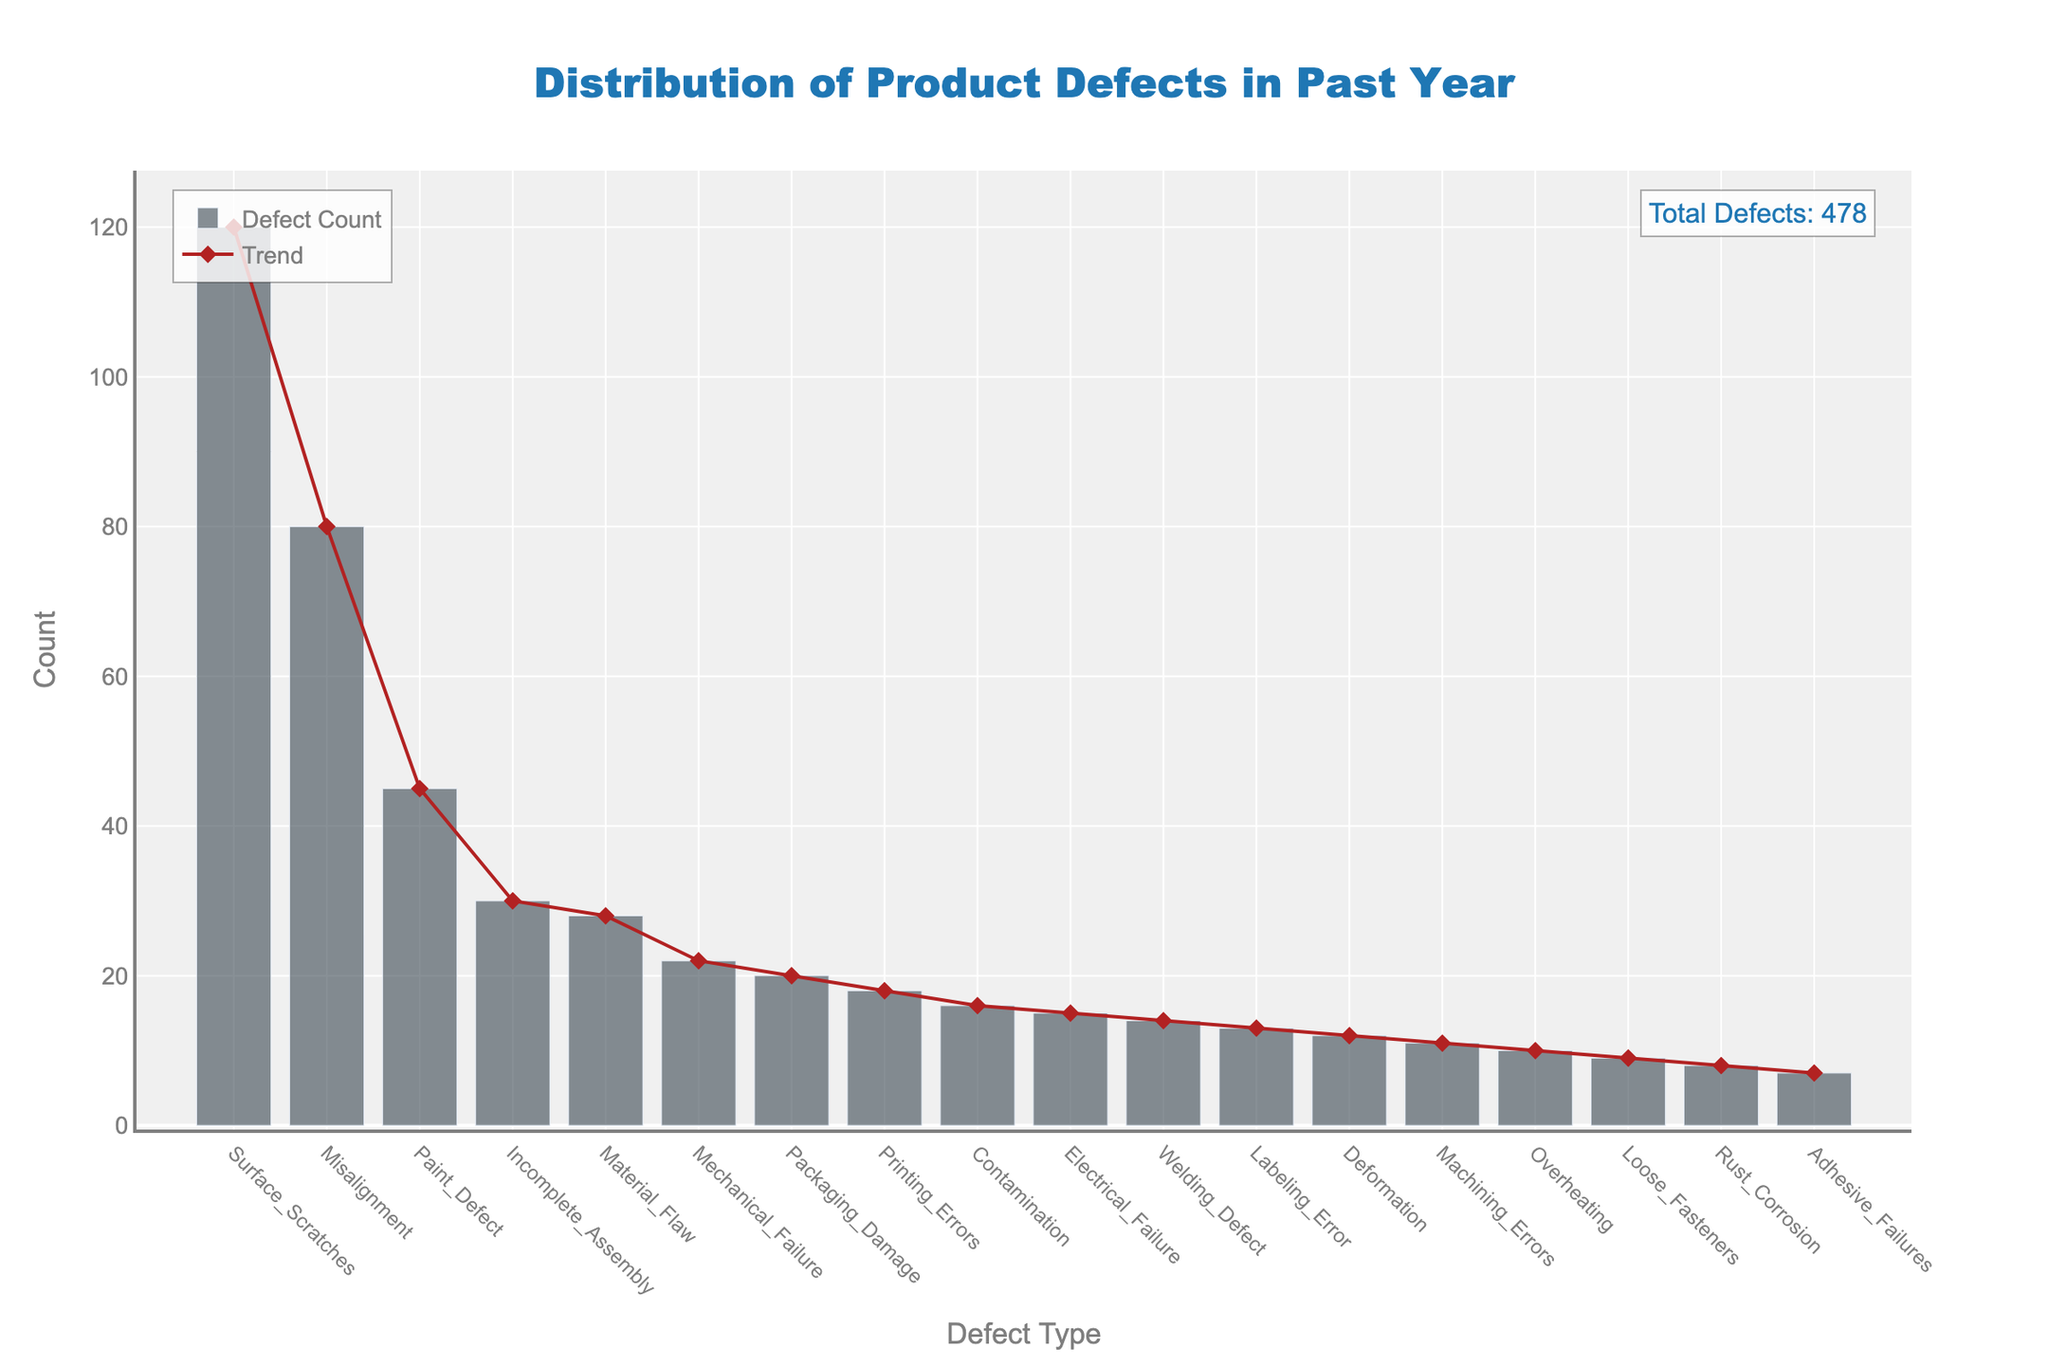What's the most common type of defect detected in the past year? The most common type of defect can be identified by the highest bar in the bar chart. The bar for "Surface Scratches" is the tallest, indicating it is the most frequent defect.
Answer: Surface Scratches What’s the title of the figure? The title of the figure is prominently displayed at the top and reads, "Distribution of Product Defects in Past Year".
Answer: Distribution of Product Defects in Past Year Which defect type has the smallest count? The smallest count can be determined by identifying the shortest bar in the bar chart. The bar for "Adhesive Failures" is the shortest.
Answer: Adhesive Failures How many total defects were detected in the past year? The total number of defects is explicitly shown in the annotation at the top right of the plot. It states "Total Defects: 468".
Answer: 468 What is the combined count of "Electrical Failure" and "Mechanical Failure"? Find the counts for "Electrical Failure" (15) and "Mechanical Failure" (22) from the y-axis values, and then sum them: 15 + 22 = 37.
Answer: 37 Which defect types have counts greater than 50? By observing the y-axis values, the defect types with bars extending past the 50 mark are "Surface Scratches" (120) and "Misalignment" (80).
Answer: Surface Scratches, Misalignment Is "Paint Defect" more or less frequent than "Electrical Failure"? Comparing the bar heights and y-axis values, "Paint Defect" has a count of 45 while "Electrical Failure" has a count of 15, making "Paint Defect" more frequent.
Answer: More frequent What trend can be observed among the defect counts? The trend line over the bars starts high with "Surface Scratches", drops gradually until "Material Flaw", and continues to show minor fluctuations among lower counts, demonstrating a descending trend overall.
Answer: Descending trend Are there more defects related to surface quality (e.g., “Surface Scratches” and “Paint Defect”) or mechanical issues (e.g., “Mechanical Failure” and “Welding Defect”)? Summing the counts for surface quality defects: "Surface Scratches" (120) + "Paint Defect" (45) = 165, and comparing them to the sum for mechanical issues: "Mechanical Failure" (22) + "Welding Defect" (14) = 36, it’s clear that surface quality defects are more frequent.
Answer: Surface quality defects What is the average defect count for the defects listed? Adding all defect counts and dividing by the number of defect types: (120 + 80 + 45 + 15 + 22 + 30 + 28 + 10 + 12 + 8 + 9 + 14 + 11 + 7 + 18 + 16 + 20 + 13) / 18 = 468 / 18 = 26.
Answer: 26 